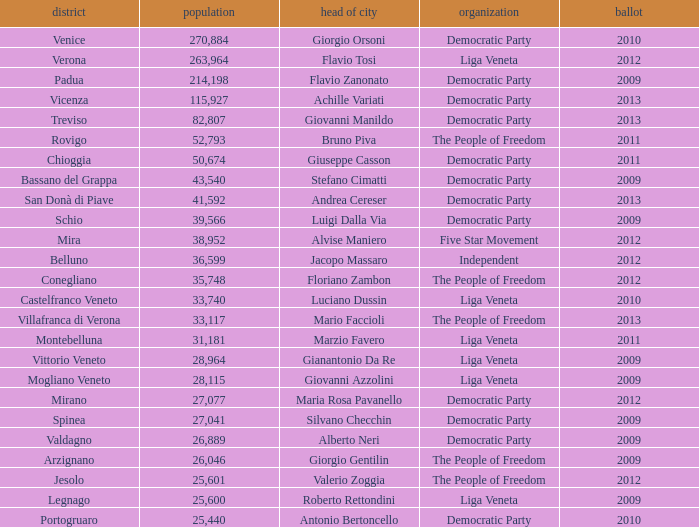What party was achille variati afilliated with? Democratic Party. 